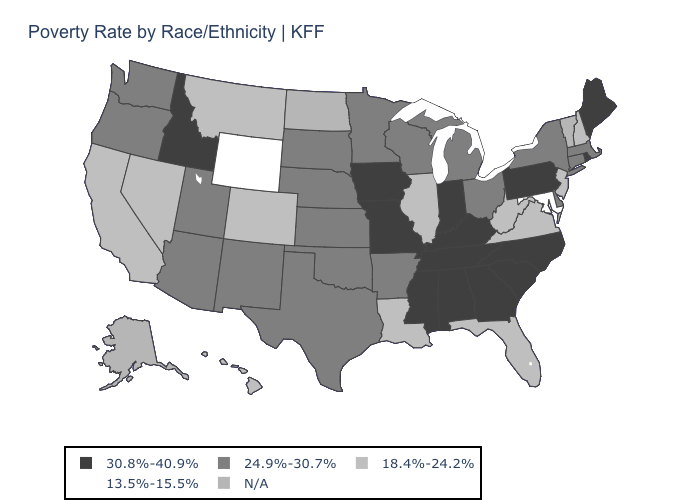What is the value of Kansas?
Concise answer only. 24.9%-30.7%. What is the value of South Dakota?
Short answer required. 24.9%-30.7%. Is the legend a continuous bar?
Give a very brief answer. No. What is the highest value in the MidWest ?
Quick response, please. 30.8%-40.9%. Name the states that have a value in the range N/A?
Give a very brief answer. Alaska, North Dakota, Vermont. What is the value of Maryland?
Answer briefly. 13.5%-15.5%. What is the highest value in the USA?
Be succinct. 30.8%-40.9%. Name the states that have a value in the range 18.4%-24.2%?
Answer briefly. California, Colorado, Florida, Hawaii, Illinois, Louisiana, Montana, Nevada, New Hampshire, New Jersey, Virginia, West Virginia. What is the lowest value in states that border West Virginia?
Keep it brief. 13.5%-15.5%. What is the value of Utah?
Be succinct. 24.9%-30.7%. Name the states that have a value in the range 30.8%-40.9%?
Short answer required. Alabama, Georgia, Idaho, Indiana, Iowa, Kentucky, Maine, Mississippi, Missouri, North Carolina, Pennsylvania, Rhode Island, South Carolina, Tennessee. What is the lowest value in the Northeast?
Concise answer only. 18.4%-24.2%. What is the value of Alaska?
Write a very short answer. N/A. Does the first symbol in the legend represent the smallest category?
Concise answer only. No. 